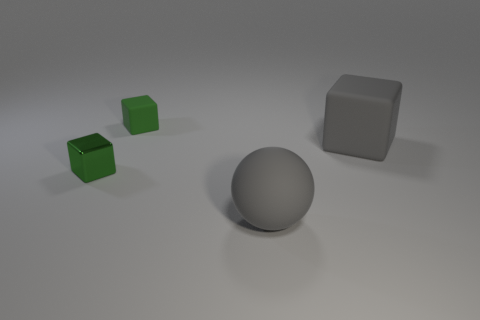There is a gray matte thing that is right of the sphere; is it the same size as the gray object that is in front of the green metal object?
Your response must be concise. Yes. How many things are small things that are left of the green rubber object or large gray objects?
Offer a very short reply. 3. There is a small object in front of the green matte thing; what is it made of?
Give a very brief answer. Metal. What material is the large gray sphere?
Provide a short and direct response. Rubber. What material is the green thing that is to the right of the tiny green thing that is to the left of the object that is behind the big matte cube?
Offer a very short reply. Rubber. Is there anything else that is the same material as the gray sphere?
Ensure brevity in your answer.  Yes. There is a rubber ball; is it the same size as the rubber block that is on the right side of the gray ball?
Offer a terse response. Yes. How many objects are matte cubes that are behind the big gray sphere or large gray objects left of the big gray block?
Your answer should be compact. 3. There is a big thing that is behind the metal object; what is its color?
Offer a very short reply. Gray. Is there a big gray rubber block that is on the right side of the gray block that is right of the tiny green shiny block?
Your answer should be very brief. No. 